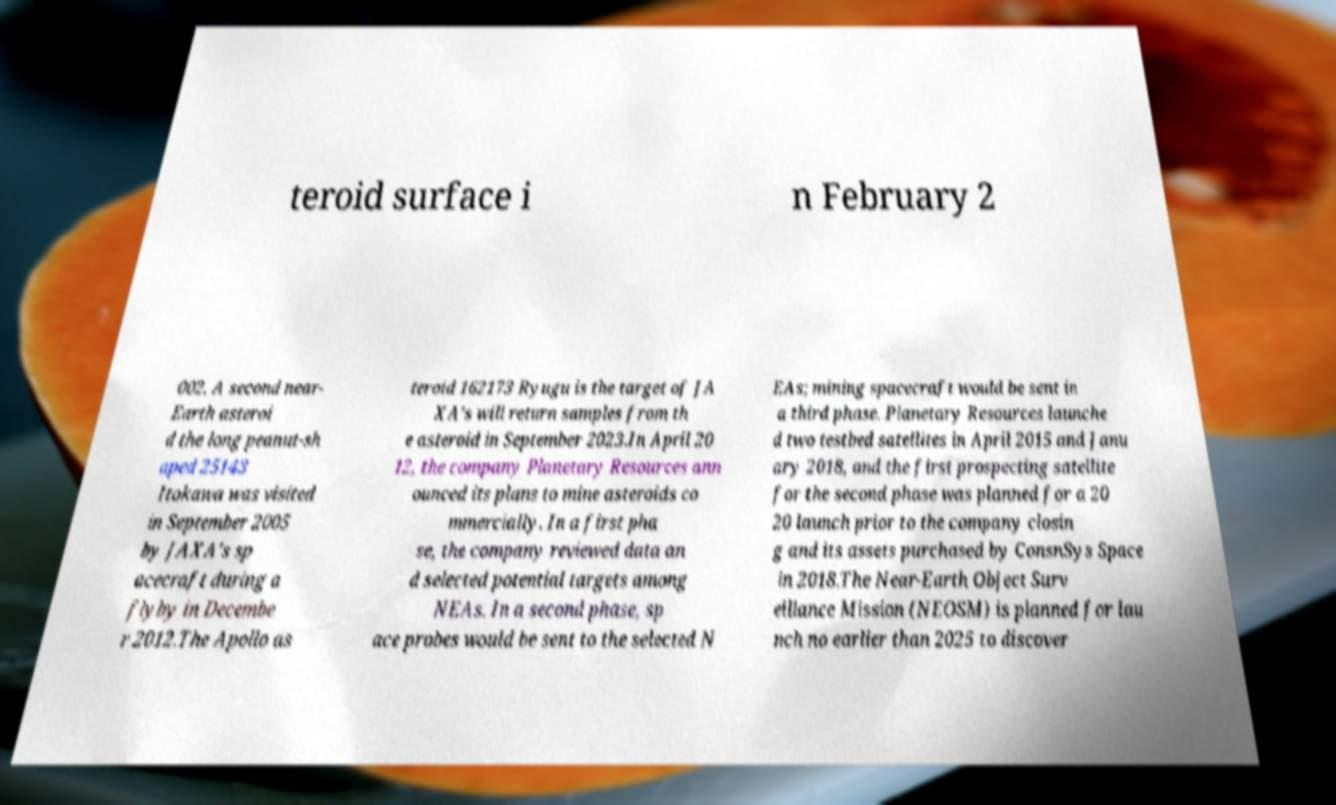Please read and relay the text visible in this image. What does it say? teroid surface i n February 2 002. A second near- Earth asteroi d the long peanut-sh aped 25143 Itokawa was visited in September 2005 by JAXA's sp acecraft during a flyby in Decembe r 2012.The Apollo as teroid 162173 Ryugu is the target of JA XA's will return samples from th e asteroid in September 2023.In April 20 12, the company Planetary Resources ann ounced its plans to mine asteroids co mmercially. In a first pha se, the company reviewed data an d selected potential targets among NEAs. In a second phase, sp ace probes would be sent to the selected N EAs; mining spacecraft would be sent in a third phase. Planetary Resources launche d two testbed satellites in April 2015 and Janu ary 2018, and the first prospecting satellite for the second phase was planned for a 20 20 launch prior to the company closin g and its assets purchased by ConsnSys Space in 2018.The Near-Earth Object Surv eillance Mission (NEOSM) is planned for lau nch no earlier than 2025 to discover 